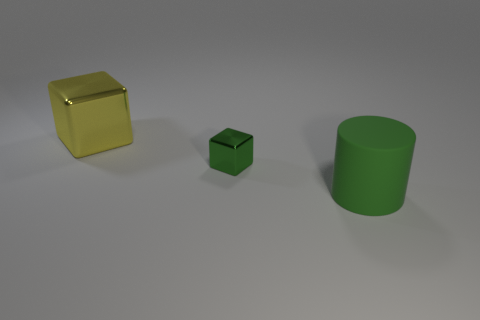Add 1 large brown matte things. How many objects exist? 4 Subtract all blocks. How many objects are left? 1 Subtract 0 blue blocks. How many objects are left? 3 Subtract all big cubes. Subtract all big blue metallic blocks. How many objects are left? 2 Add 3 small objects. How many small objects are left? 4 Add 1 big rubber cylinders. How many big rubber cylinders exist? 2 